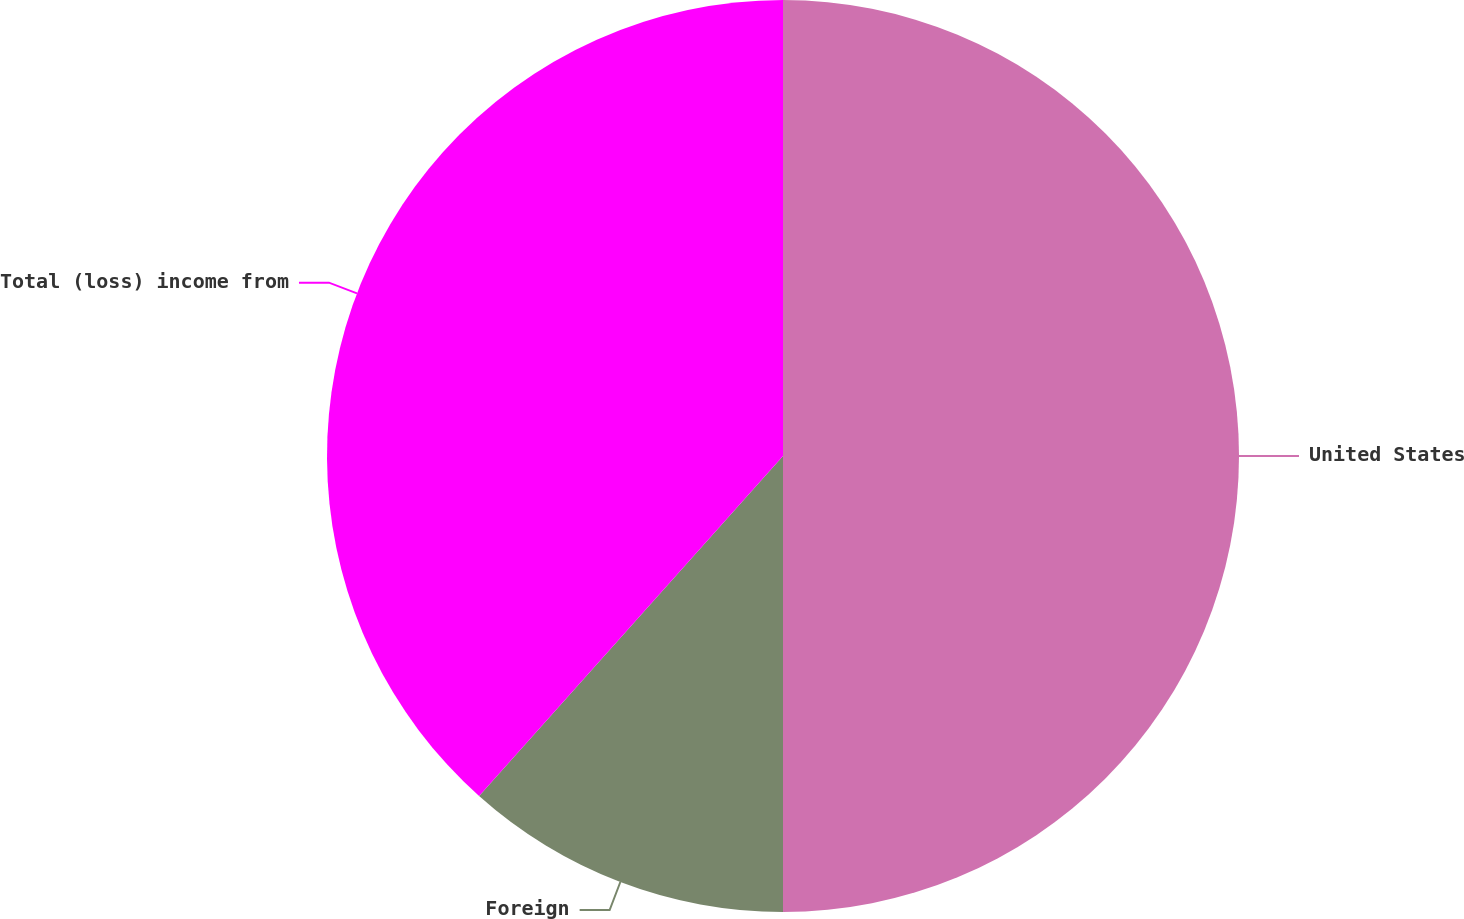Convert chart. <chart><loc_0><loc_0><loc_500><loc_500><pie_chart><fcel>United States<fcel>Foreign<fcel>Total (loss) income from<nl><fcel>50.0%<fcel>11.61%<fcel>38.39%<nl></chart> 